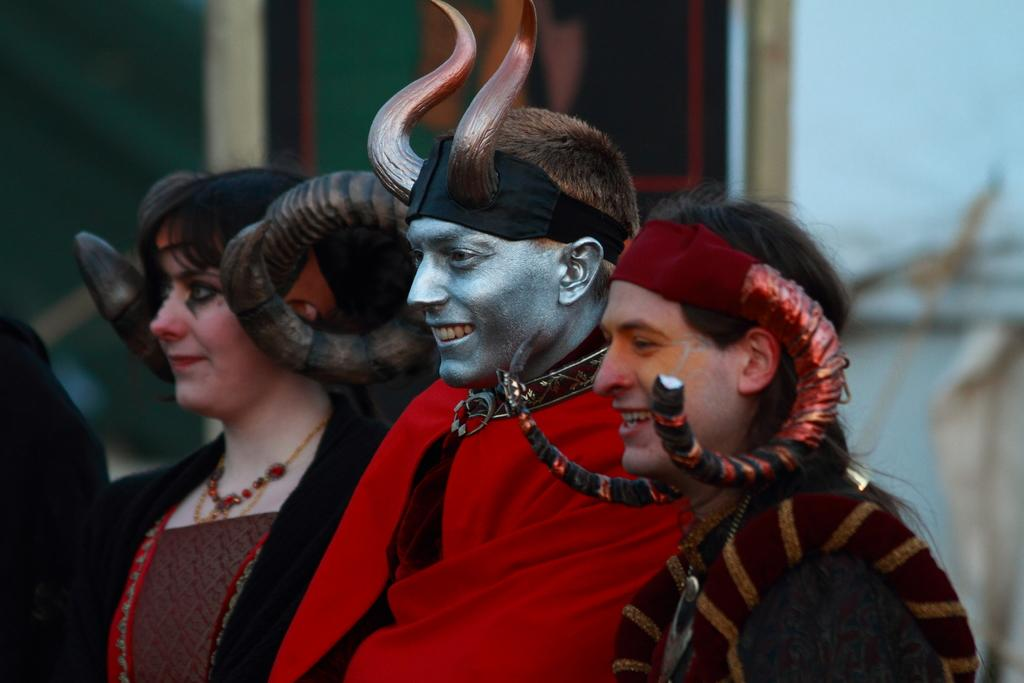What is happening in the image? There are people standing in the image. What can be seen in the background of the image? There is a wall visible in the background of the image. What month is it in the image? The month cannot be determined from the image, as there is no information about the time of year or any seasonal indicators present. 